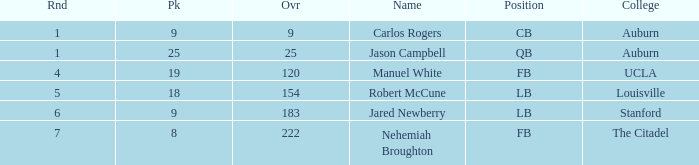Which college had an overall pick of 9? Auburn. 